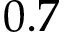Convert formula to latex. <formula><loc_0><loc_0><loc_500><loc_500>0 . 7</formula> 